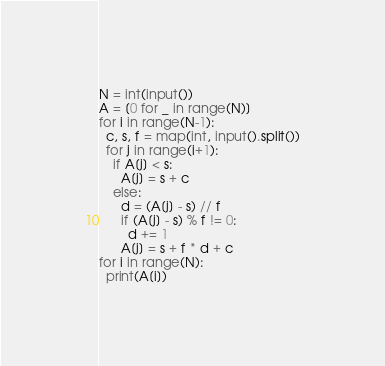<code> <loc_0><loc_0><loc_500><loc_500><_Python_>N = int(input())
A = [0 for _ in range(N)]
for i in range(N-1):
  c, s, f = map(int, input().split())
  for j in range(i+1):
    if A[j] < s:
      A[j] = s + c
    else:
      d = (A[j] - s) // f
      if (A[j] - s) % f != 0:
        d += 1
      A[j] = s + f * d + c
for i in range(N):
  print(A[i])
</code> 